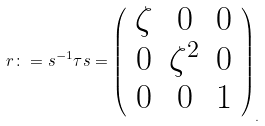Convert formula to latex. <formula><loc_0><loc_0><loc_500><loc_500>r \colon = s ^ { - 1 } \tau s = \left ( \begin{array} { c c c } \zeta & 0 & 0 \\ 0 & \zeta ^ { 2 } & 0 \\ 0 & 0 & 1 \end{array} \right ) _ { . }</formula> 